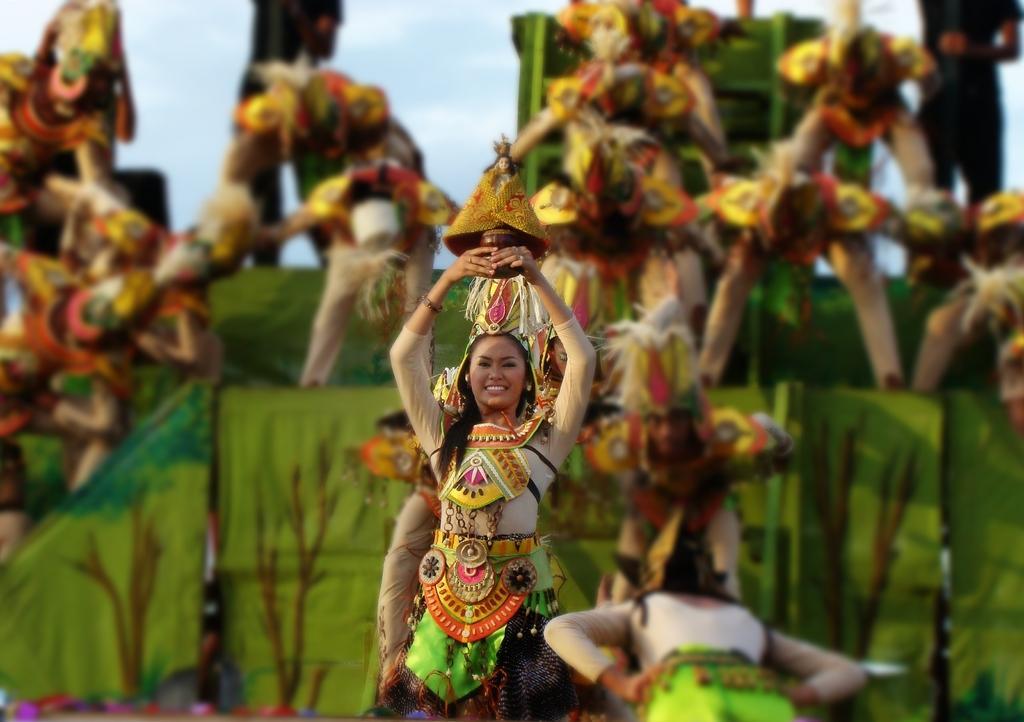Please provide a concise description of this image. This image is taken outdoors. At the top of the image there is the sky with clouds. In the background there are a few clothes which are green in color and there are a few people with different types of costumes. In the middle of the image a woman is standing and she is holding an object in her hands. She is with a smiling face. 